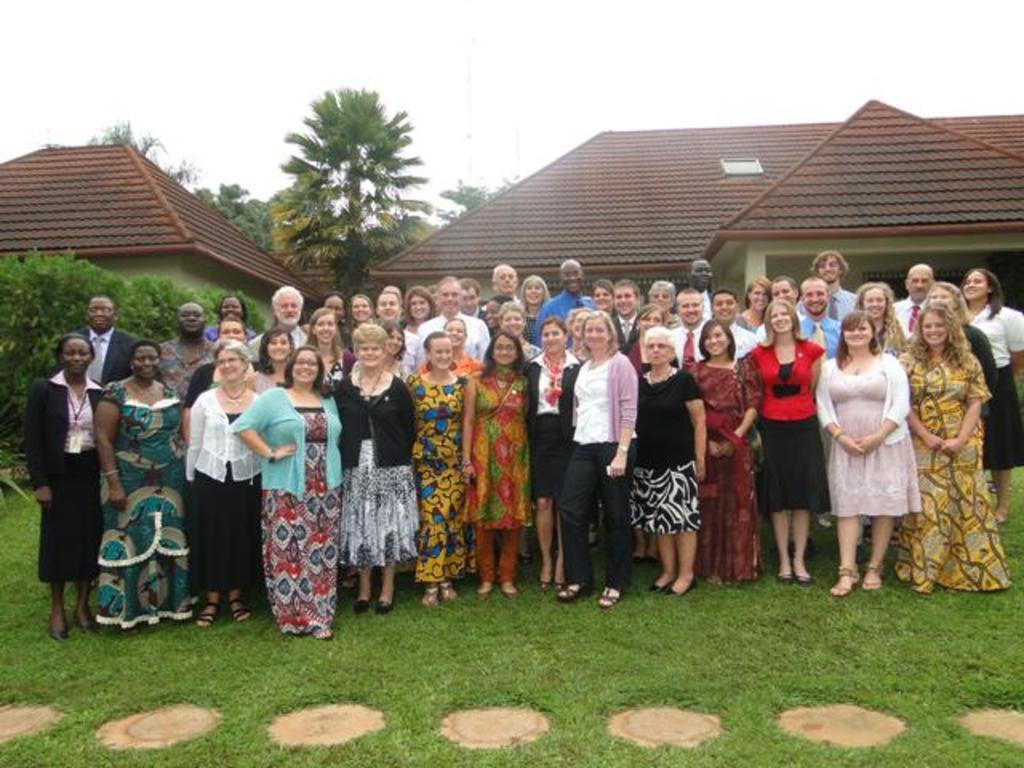In one or two sentences, can you explain what this image depicts? In this image we can see the men and also woman standing on the grass and smiling. In the background we can see the houses and also trees. Sky is also visible. 